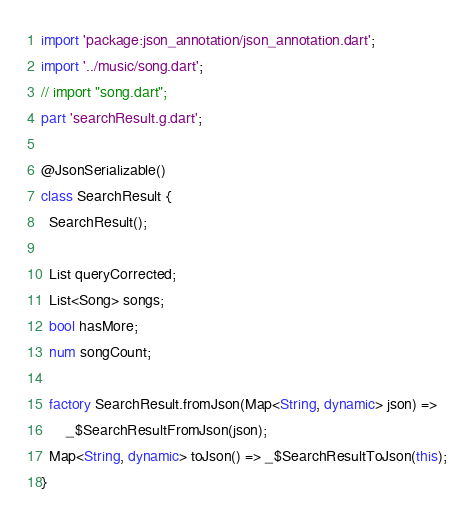<code> <loc_0><loc_0><loc_500><loc_500><_Dart_>import 'package:json_annotation/json_annotation.dart';
import '../music/song.dart';
// import "song.dart";
part 'searchResult.g.dart';

@JsonSerializable()
class SearchResult {
  SearchResult();

  List queryCorrected;
  List<Song> songs;
  bool hasMore;
  num songCount;

  factory SearchResult.fromJson(Map<String, dynamic> json) =>
      _$SearchResultFromJson(json);
  Map<String, dynamic> toJson() => _$SearchResultToJson(this);
}
</code> 